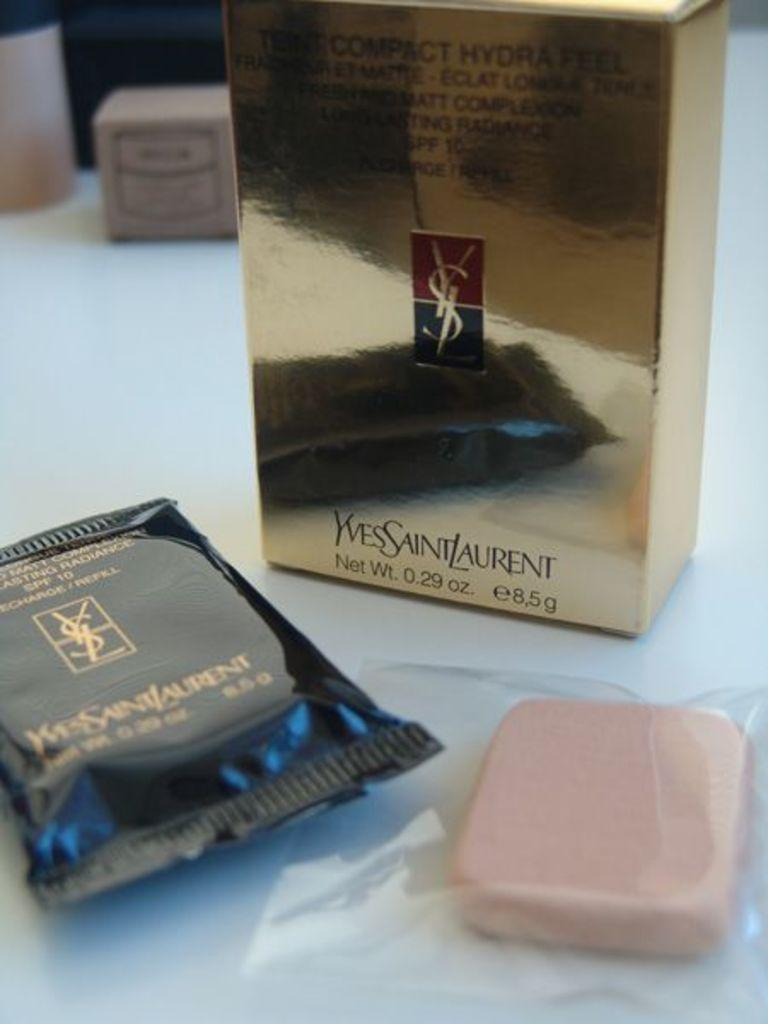Provide a one-sentence caption for the provided image. A few packs of soap called Yves Saint Laurent. 